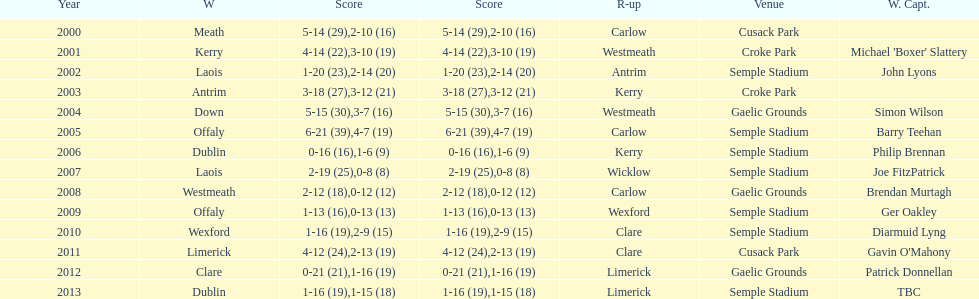Who was the winner after 2007? Laois. 